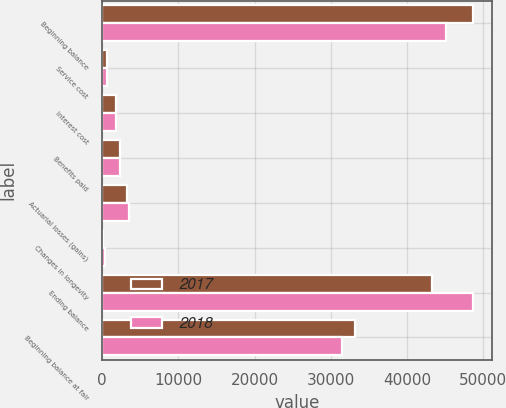Convert chart to OTSL. <chart><loc_0><loc_0><loc_500><loc_500><stacked_bar_chart><ecel><fcel>Beginning balance<fcel>Service cost<fcel>Interest cost<fcel>Benefits paid<fcel>Actuarial losses (gains)<fcel>Changes in longevity<fcel>Ending balance<fcel>Beginning balance at fair<nl><fcel>2017<fcel>48686<fcel>630<fcel>1740<fcel>2379<fcel>3281<fcel>162<fcel>43305<fcel>33095<nl><fcel>2018<fcel>45064<fcel>635<fcel>1835<fcel>2310<fcel>3536<fcel>352<fcel>48686<fcel>31417<nl></chart> 